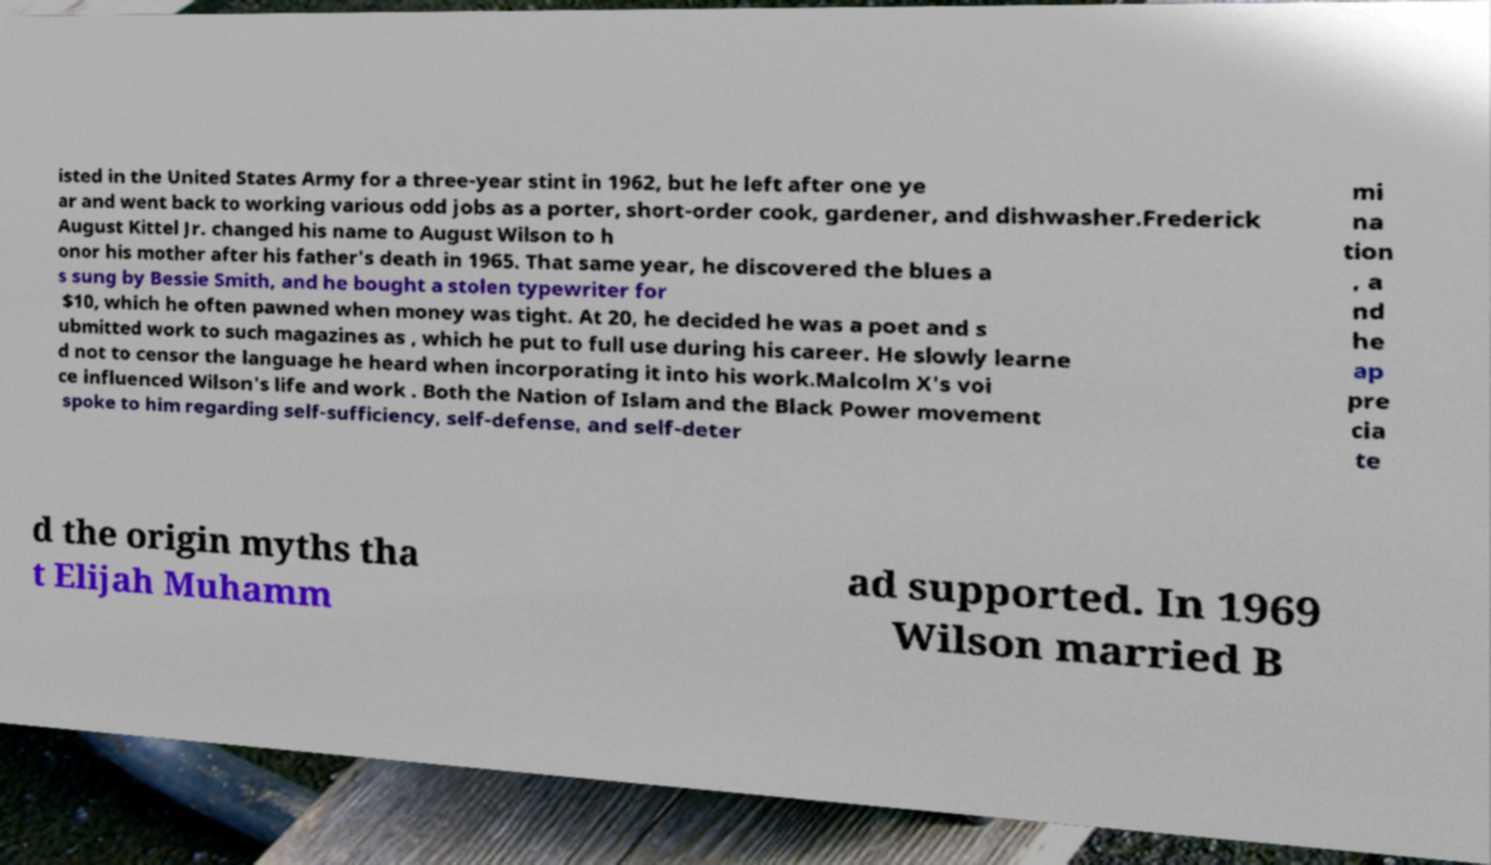What messages or text are displayed in this image? I need them in a readable, typed format. isted in the United States Army for a three-year stint in 1962, but he left after one ye ar and went back to working various odd jobs as a porter, short-order cook, gardener, and dishwasher.Frederick August Kittel Jr. changed his name to August Wilson to h onor his mother after his father's death in 1965. That same year, he discovered the blues a s sung by Bessie Smith, and he bought a stolen typewriter for $10, which he often pawned when money was tight. At 20, he decided he was a poet and s ubmitted work to such magazines as , which he put to full use during his career. He slowly learne d not to censor the language he heard when incorporating it into his work.Malcolm X's voi ce influenced Wilson's life and work . Both the Nation of Islam and the Black Power movement spoke to him regarding self-sufficiency, self-defense, and self-deter mi na tion , a nd he ap pre cia te d the origin myths tha t Elijah Muhamm ad supported. In 1969 Wilson married B 